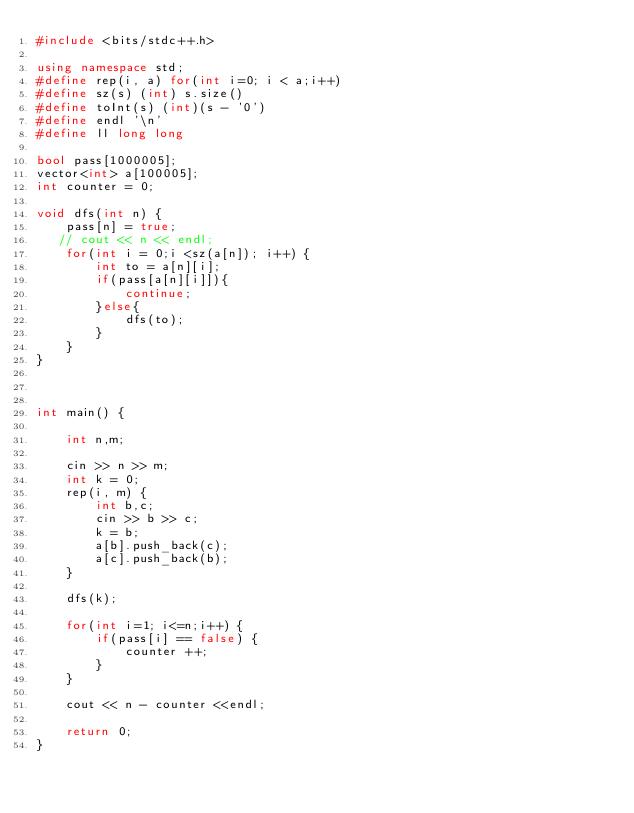<code> <loc_0><loc_0><loc_500><loc_500><_C++_>#include <bits/stdc++.h>

using namespace std;
#define rep(i, a) for(int i=0; i < a;i++)
#define sz(s) (int) s.size()
#define toInt(s) (int)(s - '0')
#define endl '\n'
#define ll long long 

bool pass[1000005];
vector<int> a[100005];
int counter = 0;

void dfs(int n) {
    pass[n] = true;
   // cout << n << endl;
    for(int i = 0;i <sz(a[n]); i++) {
        int to = a[n][i];
        if(pass[a[n][i]]){
            continue;
        }else{
            dfs(to);
        }
    }
}



int main() {

    int n,m;

    cin >> n >> m;
    int k = 0;
    rep(i, m) {
        int b,c;
        cin >> b >> c;
        k = b;
        a[b].push_back(c);
        a[c].push_back(b);
    }

    dfs(k);
    
    for(int i=1; i<=n;i++) {
        if(pass[i] == false) {
            counter ++;
        }
    }

    cout << n - counter <<endl;

    return 0;
}</code> 